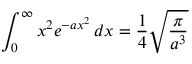Convert formula to latex. <formula><loc_0><loc_0><loc_500><loc_500>\int _ { 0 } ^ { \infty } { x ^ { 2 } e ^ { - a x ^ { 2 } } \, d x } = { \frac { 1 } { 4 } } { \sqrt { \frac { \pi } { a ^ { 3 } } } }</formula> 